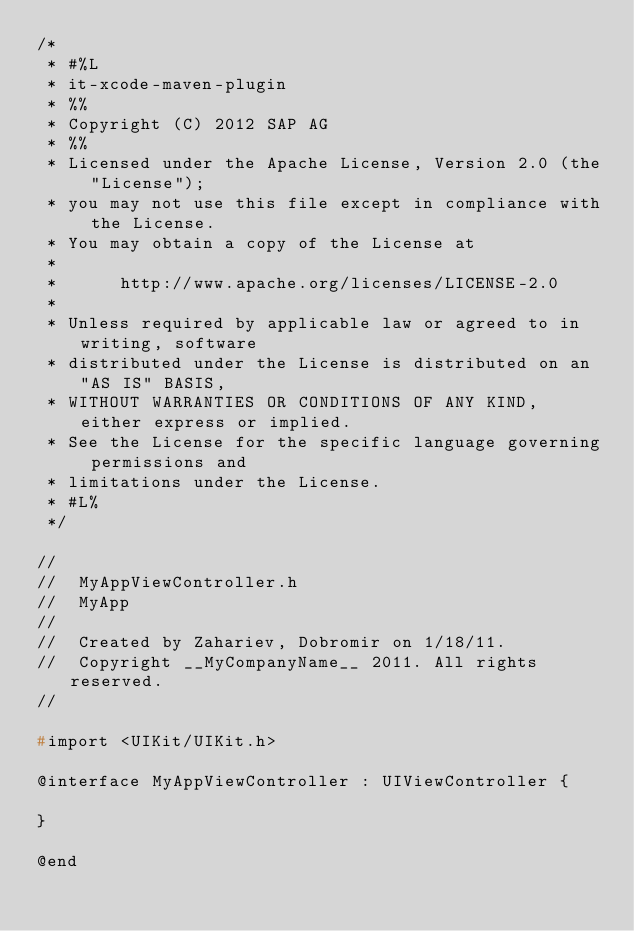<code> <loc_0><loc_0><loc_500><loc_500><_C_>/*
 * #%L
 * it-xcode-maven-plugin
 * %%
 * Copyright (C) 2012 SAP AG
 * %%
 * Licensed under the Apache License, Version 2.0 (the "License");
 * you may not use this file except in compliance with the License.
 * You may obtain a copy of the License at
 *
 *      http://www.apache.org/licenses/LICENSE-2.0
 *
 * Unless required by applicable law or agreed to in writing, software
 * distributed under the License is distributed on an "AS IS" BASIS,
 * WITHOUT WARRANTIES OR CONDITIONS OF ANY KIND, either express or implied.
 * See the License for the specific language governing permissions and
 * limitations under the License.
 * #L%
 */

//
//  MyAppViewController.h
//  MyApp
//
//  Created by Zahariev, Dobromir on 1/18/11.
//  Copyright __MyCompanyName__ 2011. All rights reserved.
//

#import <UIKit/UIKit.h>

@interface MyAppViewController : UIViewController {

}

@end

</code> 